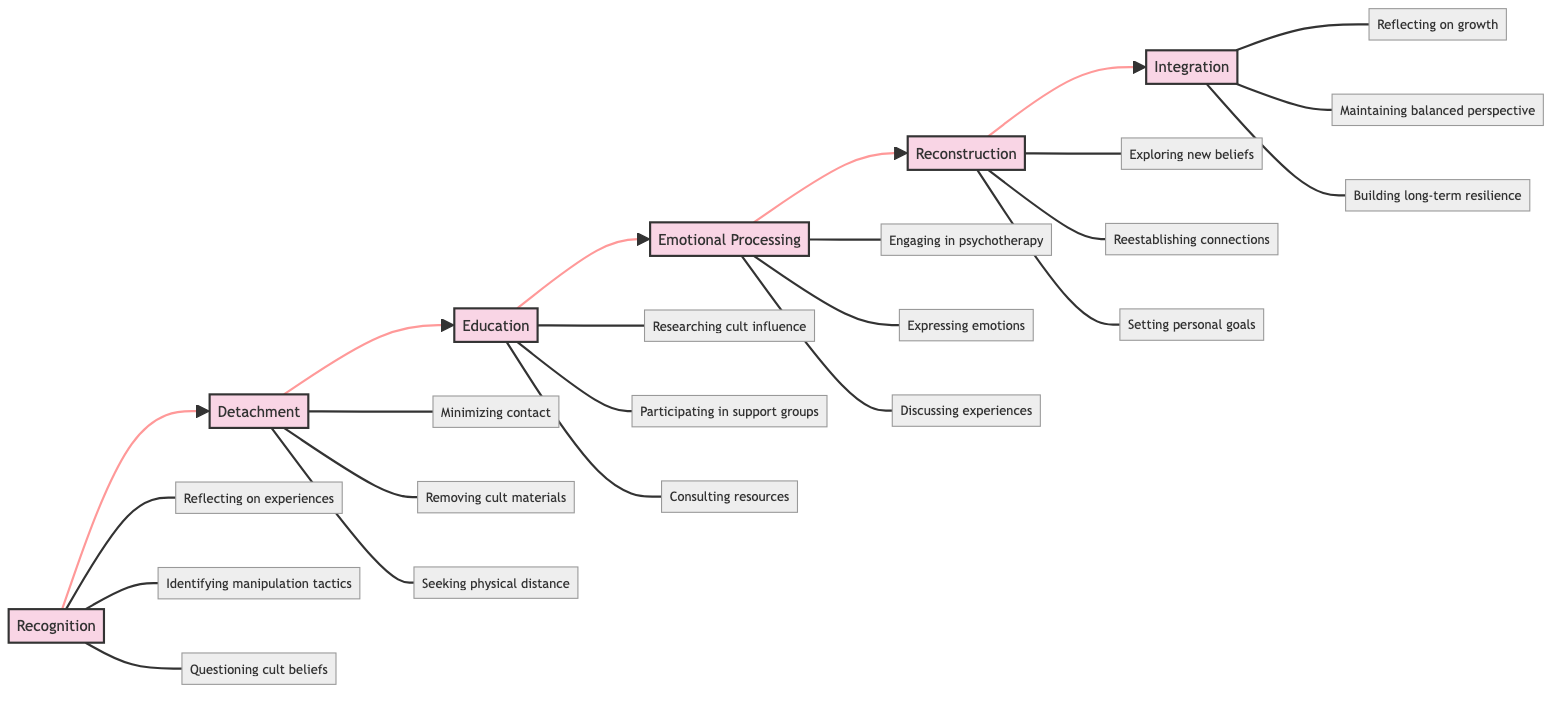What is the first stage in recovering from cult influence? The flowchart starts with the node labeled "Recognition," indicating that this is the first stage in the recovery process.
Answer: Recognition How many key activities are associated with the Education stage? Looking at the "Education" node, it branches out to three key activities: researching cult influence, participating in support groups, and consulting resources. Therefore, there are three key activities.
Answer: 3 What activity is associated with the Detachment stage? The "Detachment" stage connects to three different activities, one of which is "Minimizing contact with cult members," which is a key activity within this stage.
Answer: Minimizing contact Which stage follows Emotional Processing? From the flowchart, "Reconstruction" is the stage that directly follows "Emotional Processing," as indicated by the arrow connecting these two stages.
Answer: Reconstruction What is the last stage of the recovery process? At the end of the flowchart, the last node is labeled "Integration," indicating that this is the final stage in the psychological recovery process from cult influence.
Answer: Integration What are the key activities linked to the Reconstruction stage? The "Reconstruction" stage connects to three key activities: exploring new beliefs and values, reestablishing connections with family and friends, and setting personal goals. These activities are focused on rebuilding identity outside the cult.
Answer: Exploring new beliefs, reestablishing connections, setting personal goals How many stages are connected in the flow? The diagram showcases six distinct stages, which are connected in a linear path from Recognition to Integration. Since each stage follows consecutively to the next, there are a total of six stages.
Answer: 6 What is the purpose of the Integration stage? The "Integration" stage focuses on incorporating new experiences and learnings into a cohesive identity, reflecting on personal growth, maintaining a balanced perspective, and building long-term resilience.
Answer: Incorporating experiences into a cohesive identity 